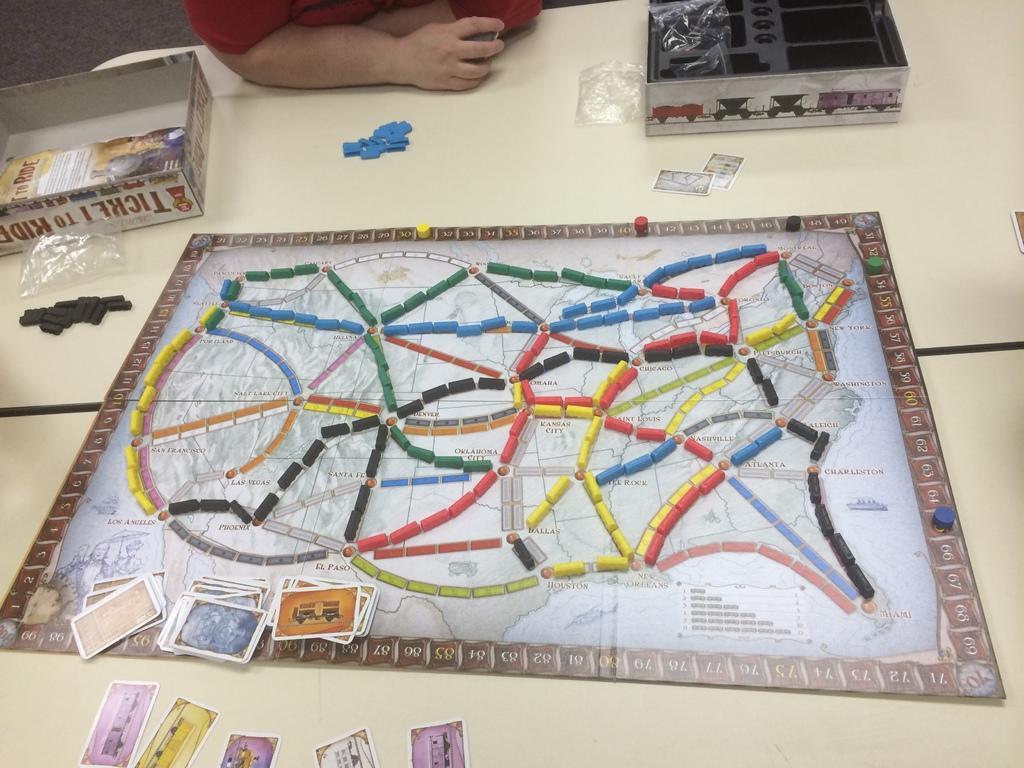In one or two sentences, can you explain what this image depicts? In this image I can see the cream color table. On the table I can see the boxes, board which is in colorful and cards. To the side I can also see the black and blue color objects and also person's hand. 